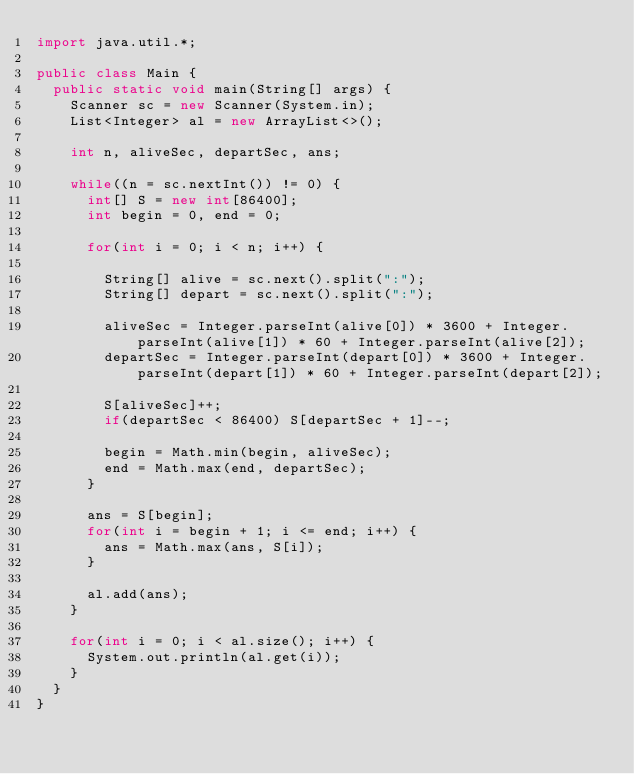Convert code to text. <code><loc_0><loc_0><loc_500><loc_500><_Java_>import java.util.*;

public class Main {
	public static void main(String[] args) {
		Scanner sc = new Scanner(System.in);
		List<Integer> al = new ArrayList<>();
		
		int n, aliveSec, departSec, ans;
		
		while((n = sc.nextInt()) != 0) {
			int[] S = new int[86400];
			int begin = 0, end = 0;
			
			for(int i = 0; i < n; i++) {
				
				String[] alive = sc.next().split(":");
				String[] depart = sc.next().split(":");
				
				aliveSec = Integer.parseInt(alive[0]) * 3600 + Integer.parseInt(alive[1]) * 60 + Integer.parseInt(alive[2]);
				departSec = Integer.parseInt(depart[0]) * 3600 + Integer.parseInt(depart[1]) * 60 + Integer.parseInt(depart[2]);
				
				S[aliveSec]++;
				if(departSec < 86400)	S[departSec + 1]--;
				
				begin = Math.min(begin, aliveSec);
				end = Math.max(end, departSec);
			}
			
			ans = S[begin];
			for(int i = begin + 1; i <= end; i++) {
				ans = Math.max(ans, S[i]);
			}
			
			al.add(ans);
		}
		
		for(int i = 0; i < al.size(); i++) {
			System.out.println(al.get(i));
		}
	}
}</code> 